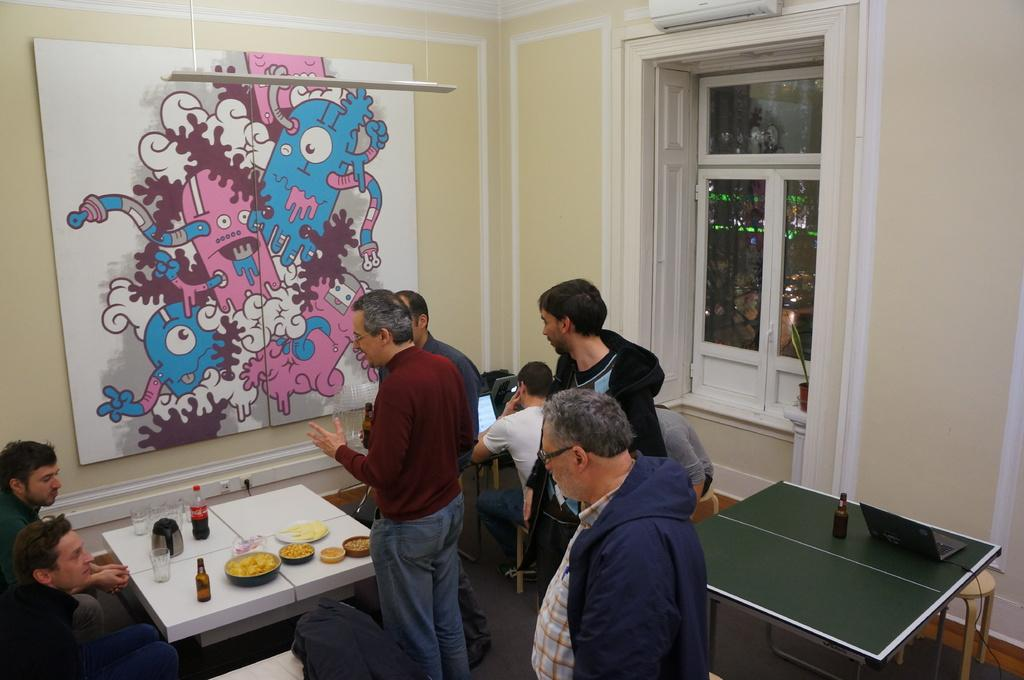What is the main object in the image? There is a board in the image. What type of structure is visible in the image? There is a wall in the image. What can be seen through the wall? There is a window in the image. What piece of furniture is present in the image? There is a table in the image. What are the people in the image doing? There are people standing in the image. What items are on the table? There are bottles, glasses, and plates on the table. Can you see a laborer working on a mountain in the image? There is no laborer or mountain present in the image. Are there any rats visible on the table in the image? There are no rats present in the image. 